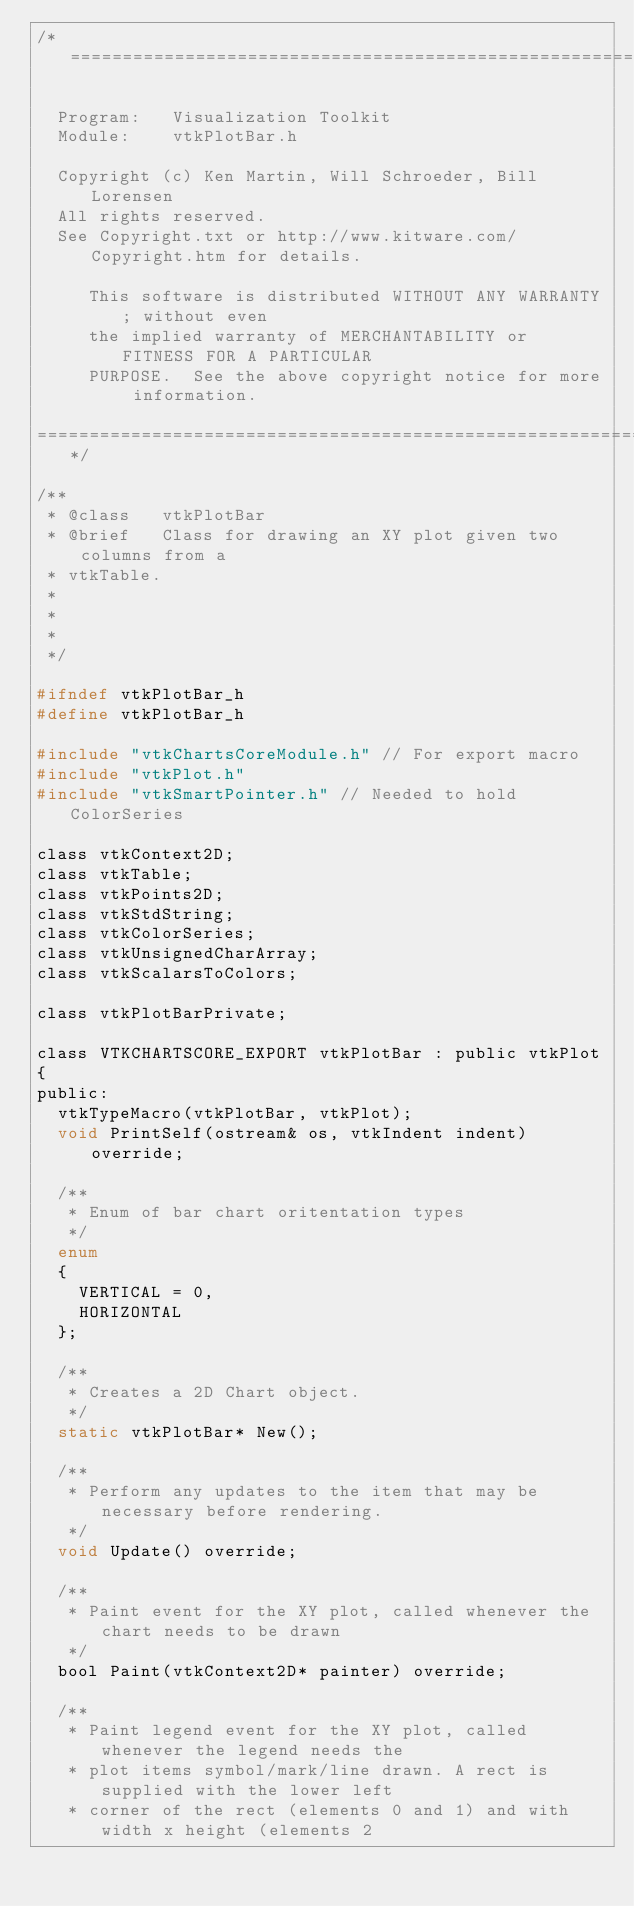Convert code to text. <code><loc_0><loc_0><loc_500><loc_500><_C_>/*=========================================================================

  Program:   Visualization Toolkit
  Module:    vtkPlotBar.h

  Copyright (c) Ken Martin, Will Schroeder, Bill Lorensen
  All rights reserved.
  See Copyright.txt or http://www.kitware.com/Copyright.htm for details.

     This software is distributed WITHOUT ANY WARRANTY; without even
     the implied warranty of MERCHANTABILITY or FITNESS FOR A PARTICULAR
     PURPOSE.  See the above copyright notice for more information.

=========================================================================*/

/**
 * @class   vtkPlotBar
 * @brief   Class for drawing an XY plot given two columns from a
 * vtkTable.
 *
 *
 *
 */

#ifndef vtkPlotBar_h
#define vtkPlotBar_h

#include "vtkChartsCoreModule.h" // For export macro
#include "vtkPlot.h"
#include "vtkSmartPointer.h" // Needed to hold ColorSeries

class vtkContext2D;
class vtkTable;
class vtkPoints2D;
class vtkStdString;
class vtkColorSeries;
class vtkUnsignedCharArray;
class vtkScalarsToColors;

class vtkPlotBarPrivate;

class VTKCHARTSCORE_EXPORT vtkPlotBar : public vtkPlot
{
public:
  vtkTypeMacro(vtkPlotBar, vtkPlot);
  void PrintSelf(ostream& os, vtkIndent indent) override;

  /**
   * Enum of bar chart oritentation types
   */
  enum
  {
    VERTICAL = 0,
    HORIZONTAL
  };

  /**
   * Creates a 2D Chart object.
   */
  static vtkPlotBar* New();

  /**
   * Perform any updates to the item that may be necessary before rendering.
   */
  void Update() override;

  /**
   * Paint event for the XY plot, called whenever the chart needs to be drawn
   */
  bool Paint(vtkContext2D* painter) override;

  /**
   * Paint legend event for the XY plot, called whenever the legend needs the
   * plot items symbol/mark/line drawn. A rect is supplied with the lower left
   * corner of the rect (elements 0 and 1) and with width x height (elements 2</code> 